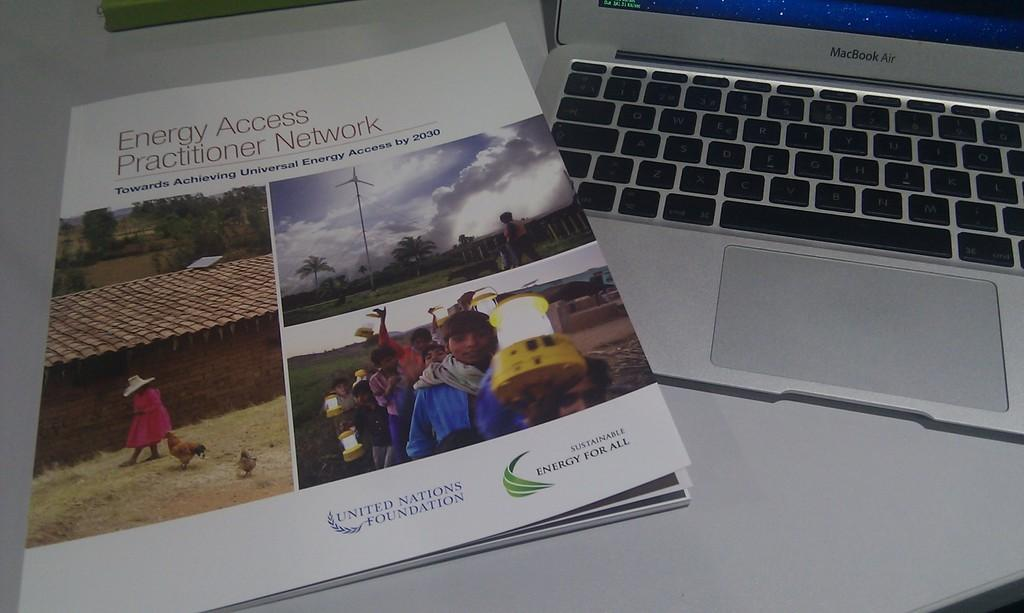<image>
Write a terse but informative summary of the picture. a phamplet for the united nations foundation sitting on top of a laptop keyboard 